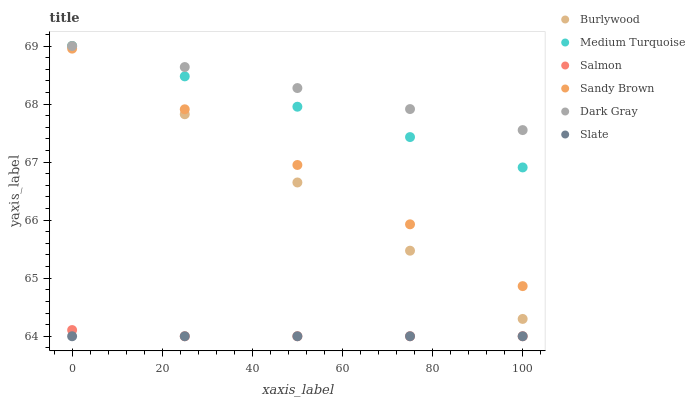Does Slate have the minimum area under the curve?
Answer yes or no. Yes. Does Dark Gray have the maximum area under the curve?
Answer yes or no. Yes. Does Salmon have the minimum area under the curve?
Answer yes or no. No. Does Salmon have the maximum area under the curve?
Answer yes or no. No. Is Slate the smoothest?
Answer yes or no. Yes. Is Sandy Brown the roughest?
Answer yes or no. Yes. Is Salmon the smoothest?
Answer yes or no. No. Is Salmon the roughest?
Answer yes or no. No. Does Slate have the lowest value?
Answer yes or no. Yes. Does Dark Gray have the lowest value?
Answer yes or no. No. Does Medium Turquoise have the highest value?
Answer yes or no. Yes. Does Salmon have the highest value?
Answer yes or no. No. Is Slate less than Sandy Brown?
Answer yes or no. Yes. Is Medium Turquoise greater than Slate?
Answer yes or no. Yes. Does Burlywood intersect Medium Turquoise?
Answer yes or no. Yes. Is Burlywood less than Medium Turquoise?
Answer yes or no. No. Is Burlywood greater than Medium Turquoise?
Answer yes or no. No. Does Slate intersect Sandy Brown?
Answer yes or no. No. 